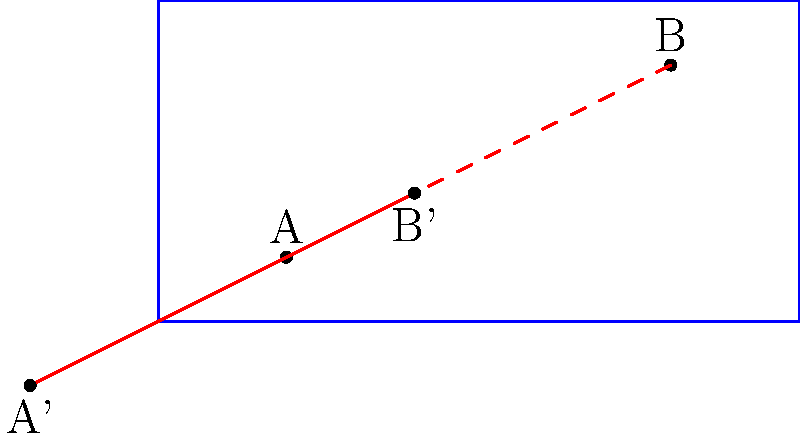In a water polo match, player A is at position (2,1) and player B is at position (8,4) in the pool. The coach wants to implement a new strategy by translating both players' positions by the vector $\langle -4, -2 \rangle$. What are the new coordinates of player B after this translation? To solve this problem, we need to follow these steps:

1. Identify the original position of player B: (8,4)

2. Understand the translation vector: $\langle -4, -2 \rangle$

3. Apply the translation to player B's coordinates:
   - X-coordinate: $8 + (-4) = 4$
   - Y-coordinate: $4 + (-2) = 2$

4. The new position of player B is the result of this translation: (4,2)

We can verify this result by observing that the line segment connecting the original positions (A and B) is parallel to the line segment connecting the translated positions (A' and B'). This is a key property of translations in transformational geometry.
Answer: (4,2) 